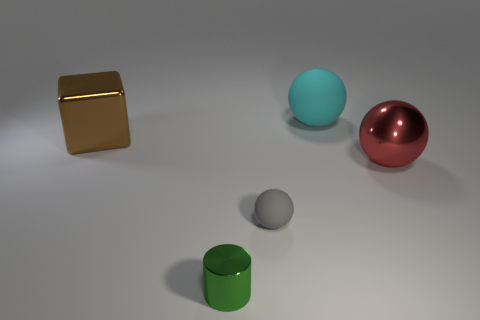Add 5 green metallic objects. How many green metallic objects exist? 6 Add 1 big metallic blocks. How many objects exist? 6 Subtract all red balls. How many balls are left? 2 Subtract all gray balls. How many balls are left? 2 Subtract 0 red blocks. How many objects are left? 5 Subtract all blocks. How many objects are left? 4 Subtract all green balls. Subtract all blue blocks. How many balls are left? 3 Subtract all green cylinders. How many red balls are left? 1 Subtract all big red balls. Subtract all gray matte spheres. How many objects are left? 3 Add 3 matte spheres. How many matte spheres are left? 5 